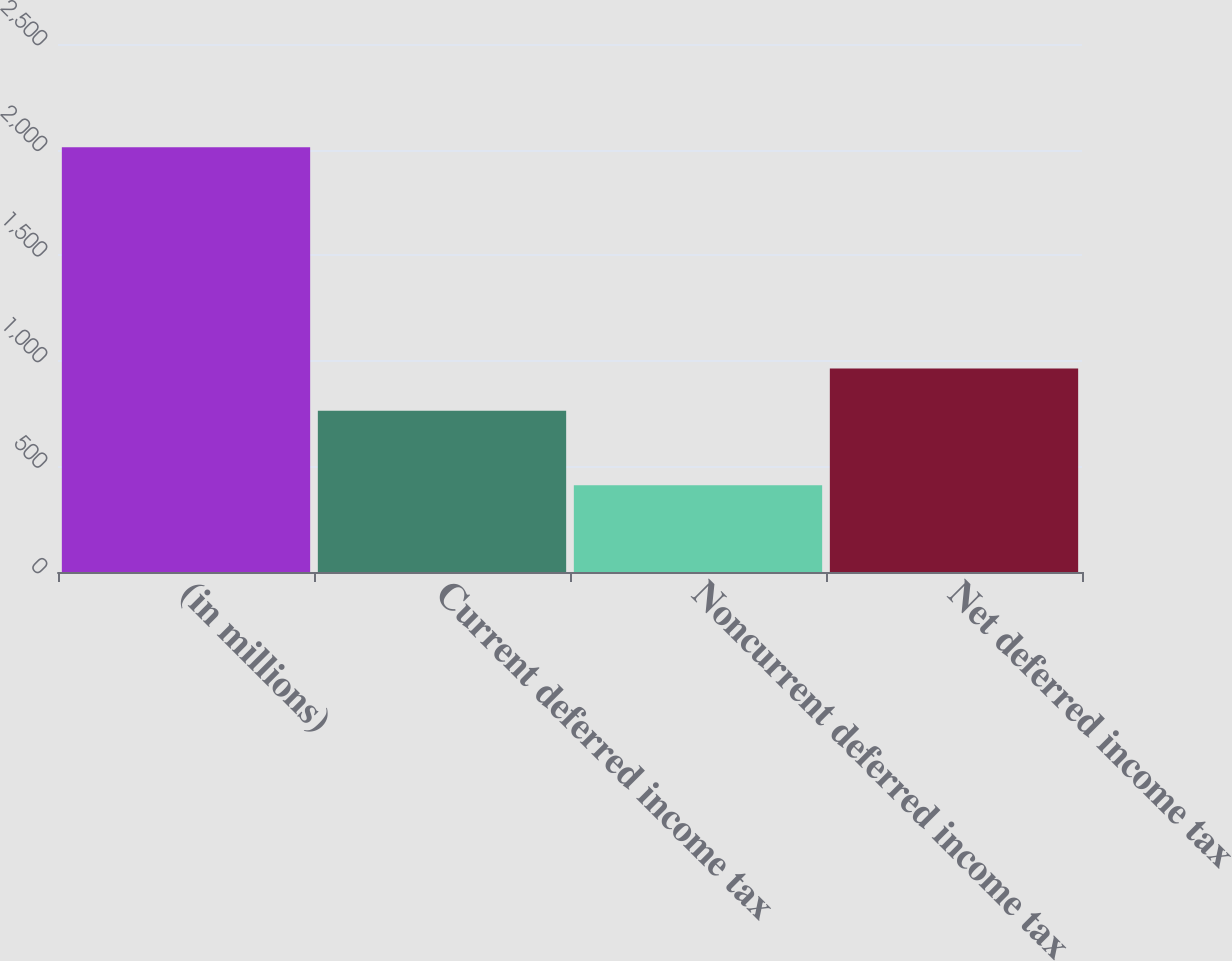<chart> <loc_0><loc_0><loc_500><loc_500><bar_chart><fcel>(in millions)<fcel>Current deferred income tax<fcel>Noncurrent deferred income tax<fcel>Net deferred income tax<nl><fcel>2011<fcel>763<fcel>410.2<fcel>963.1<nl></chart> 